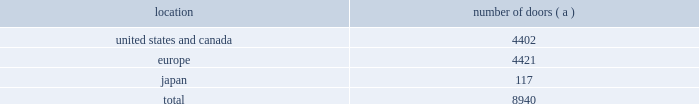Table of contents worldwide distribution channels the table presents the number of doors by geographic location , in which ralph lauren-branded products distributed by our wholesale segment were sold to consumers in our primary channels of distribution as of april 3 , 2010 : number of location doors ( a ) .
( a ) in asia-pacific , our products are primarily distributed through concessions-based sales arrangements .
In addition , american living and chaps-branded products distributed by our wholesale segment were sold domestically through approximately 1700 doors as of april 3 , 2010 .
We have five key department-store customers that generate significant sales volume .
For fiscal 2010 , these customers in the aggregate accounted for approximately 45% ( 45 % ) of all wholesale revenues , with macy 2019s , inc .
Representing approximately 18% ( 18 % ) of these revenues .
Our product brands are sold primarily through their own sales forces .
Our wholesale segment maintains its primary showrooms in new york city .
In addition , we maintain regional showrooms in atlanta , chicago , dallas , milan , paris , london , munich , madrid and stockholm .
Shop-within-shops .
As a critical element of our distribution to department stores , we and our licensing partners utilize shop- within-shops to enhance brand recognition , to permit more complete merchandising of our lines by the department stores and to differentiate the presentation of products .
Shop-within-shops fixed assets primarily include items such as customized freestanding fixtures , wall cases and components , decorative items and flooring .
As of april 3 , 2010 , we had approximately 14000 shop-within-shops dedicated to our ralph lauren-branded wholesale products worldwide .
Excluding significantly larger shop-within-shops in key department store locations , the size of our shop-within-shops typically ranges from approximately 300 to 6000 square feet .
We normally share in the cost of these shop-within-shops with our wholesale customers .
Basic stock replenishment program .
Basic products such as knit shirts , chino pants and oxford cloth shirts can be ordered at any time through our basic stock replenishment programs .
We generally ship these products within three-to-five days of order receipt .
Our retail segment as of april 3 , 2010 , our retail segment consisted of 179 full-price retail stores and 171 factory stores worldwide , totaling approximately 2.6 million square feet , 281 concessions-based shop-within-shops and two e-commerce websites .
The extension of our direct-to-consumer reach is a primary long-term strategic goal .
Full-price retail stores our full-price retail stores reinforce the luxury image and distinct sensibility of our brands and feature exclusive lines that are not sold in domestic department stores .
We opened 3 new full-price stores and closed 3 full-price stores in fiscal 2010 .
In addition , we assumed 16 full-price stores in connection with the asia-pacific .
What percentage of doors in the wholesale segment as of april 3 , 2010 where in the europe geography? 
Computations: (4421 / 8940)
Answer: 0.49452. 